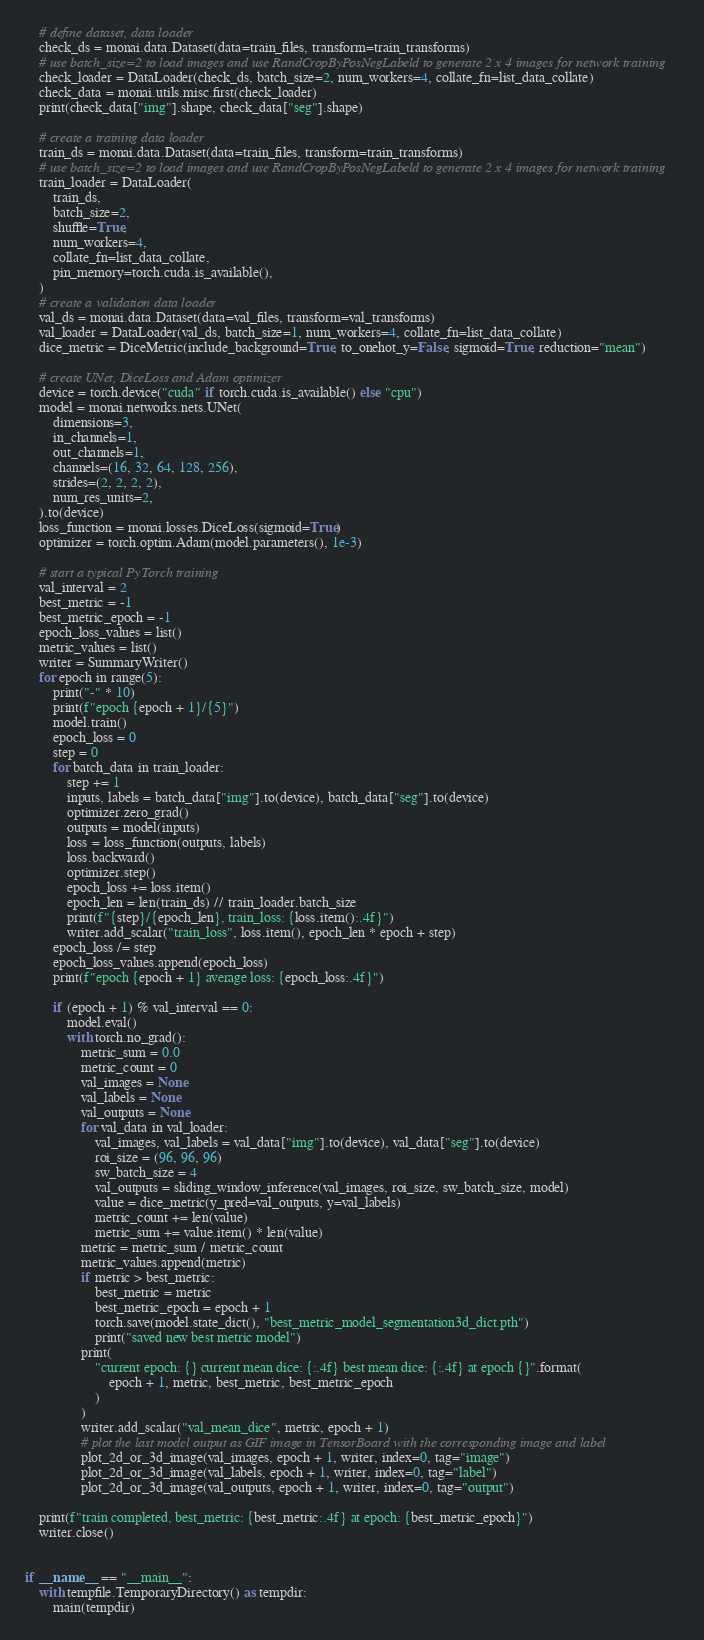Convert code to text. <code><loc_0><loc_0><loc_500><loc_500><_Python_>    # define dataset, data loader
    check_ds = monai.data.Dataset(data=train_files, transform=train_transforms)
    # use batch_size=2 to load images and use RandCropByPosNegLabeld to generate 2 x 4 images for network training
    check_loader = DataLoader(check_ds, batch_size=2, num_workers=4, collate_fn=list_data_collate)
    check_data = monai.utils.misc.first(check_loader)
    print(check_data["img"].shape, check_data["seg"].shape)

    # create a training data loader
    train_ds = monai.data.Dataset(data=train_files, transform=train_transforms)
    # use batch_size=2 to load images and use RandCropByPosNegLabeld to generate 2 x 4 images for network training
    train_loader = DataLoader(
        train_ds,
        batch_size=2,
        shuffle=True,
        num_workers=4,
        collate_fn=list_data_collate,
        pin_memory=torch.cuda.is_available(),
    )
    # create a validation data loader
    val_ds = monai.data.Dataset(data=val_files, transform=val_transforms)
    val_loader = DataLoader(val_ds, batch_size=1, num_workers=4, collate_fn=list_data_collate)
    dice_metric = DiceMetric(include_background=True, to_onehot_y=False, sigmoid=True, reduction="mean")

    # create UNet, DiceLoss and Adam optimizer
    device = torch.device("cuda" if torch.cuda.is_available() else "cpu")
    model = monai.networks.nets.UNet(
        dimensions=3,
        in_channels=1,
        out_channels=1,
        channels=(16, 32, 64, 128, 256),
        strides=(2, 2, 2, 2),
        num_res_units=2,
    ).to(device)
    loss_function = monai.losses.DiceLoss(sigmoid=True)
    optimizer = torch.optim.Adam(model.parameters(), 1e-3)

    # start a typical PyTorch training
    val_interval = 2
    best_metric = -1
    best_metric_epoch = -1
    epoch_loss_values = list()
    metric_values = list()
    writer = SummaryWriter()
    for epoch in range(5):
        print("-" * 10)
        print(f"epoch {epoch + 1}/{5}")
        model.train()
        epoch_loss = 0
        step = 0
        for batch_data in train_loader:
            step += 1
            inputs, labels = batch_data["img"].to(device), batch_data["seg"].to(device)
            optimizer.zero_grad()
            outputs = model(inputs)
            loss = loss_function(outputs, labels)
            loss.backward()
            optimizer.step()
            epoch_loss += loss.item()
            epoch_len = len(train_ds) // train_loader.batch_size
            print(f"{step}/{epoch_len}, train_loss: {loss.item():.4f}")
            writer.add_scalar("train_loss", loss.item(), epoch_len * epoch + step)
        epoch_loss /= step
        epoch_loss_values.append(epoch_loss)
        print(f"epoch {epoch + 1} average loss: {epoch_loss:.4f}")

        if (epoch + 1) % val_interval == 0:
            model.eval()
            with torch.no_grad():
                metric_sum = 0.0
                metric_count = 0
                val_images = None
                val_labels = None
                val_outputs = None
                for val_data in val_loader:
                    val_images, val_labels = val_data["img"].to(device), val_data["seg"].to(device)
                    roi_size = (96, 96, 96)
                    sw_batch_size = 4
                    val_outputs = sliding_window_inference(val_images, roi_size, sw_batch_size, model)
                    value = dice_metric(y_pred=val_outputs, y=val_labels)
                    metric_count += len(value)
                    metric_sum += value.item() * len(value)
                metric = metric_sum / metric_count
                metric_values.append(metric)
                if metric > best_metric:
                    best_metric = metric
                    best_metric_epoch = epoch + 1
                    torch.save(model.state_dict(), "best_metric_model_segmentation3d_dict.pth")
                    print("saved new best metric model")
                print(
                    "current epoch: {} current mean dice: {:.4f} best mean dice: {:.4f} at epoch {}".format(
                        epoch + 1, metric, best_metric, best_metric_epoch
                    )
                )
                writer.add_scalar("val_mean_dice", metric, epoch + 1)
                # plot the last model output as GIF image in TensorBoard with the corresponding image and label
                plot_2d_or_3d_image(val_images, epoch + 1, writer, index=0, tag="image")
                plot_2d_or_3d_image(val_labels, epoch + 1, writer, index=0, tag="label")
                plot_2d_or_3d_image(val_outputs, epoch + 1, writer, index=0, tag="output")

    print(f"train completed, best_metric: {best_metric:.4f} at epoch: {best_metric_epoch}")
    writer.close()


if __name__ == "__main__":
    with tempfile.TemporaryDirectory() as tempdir:
        main(tempdir)
</code> 